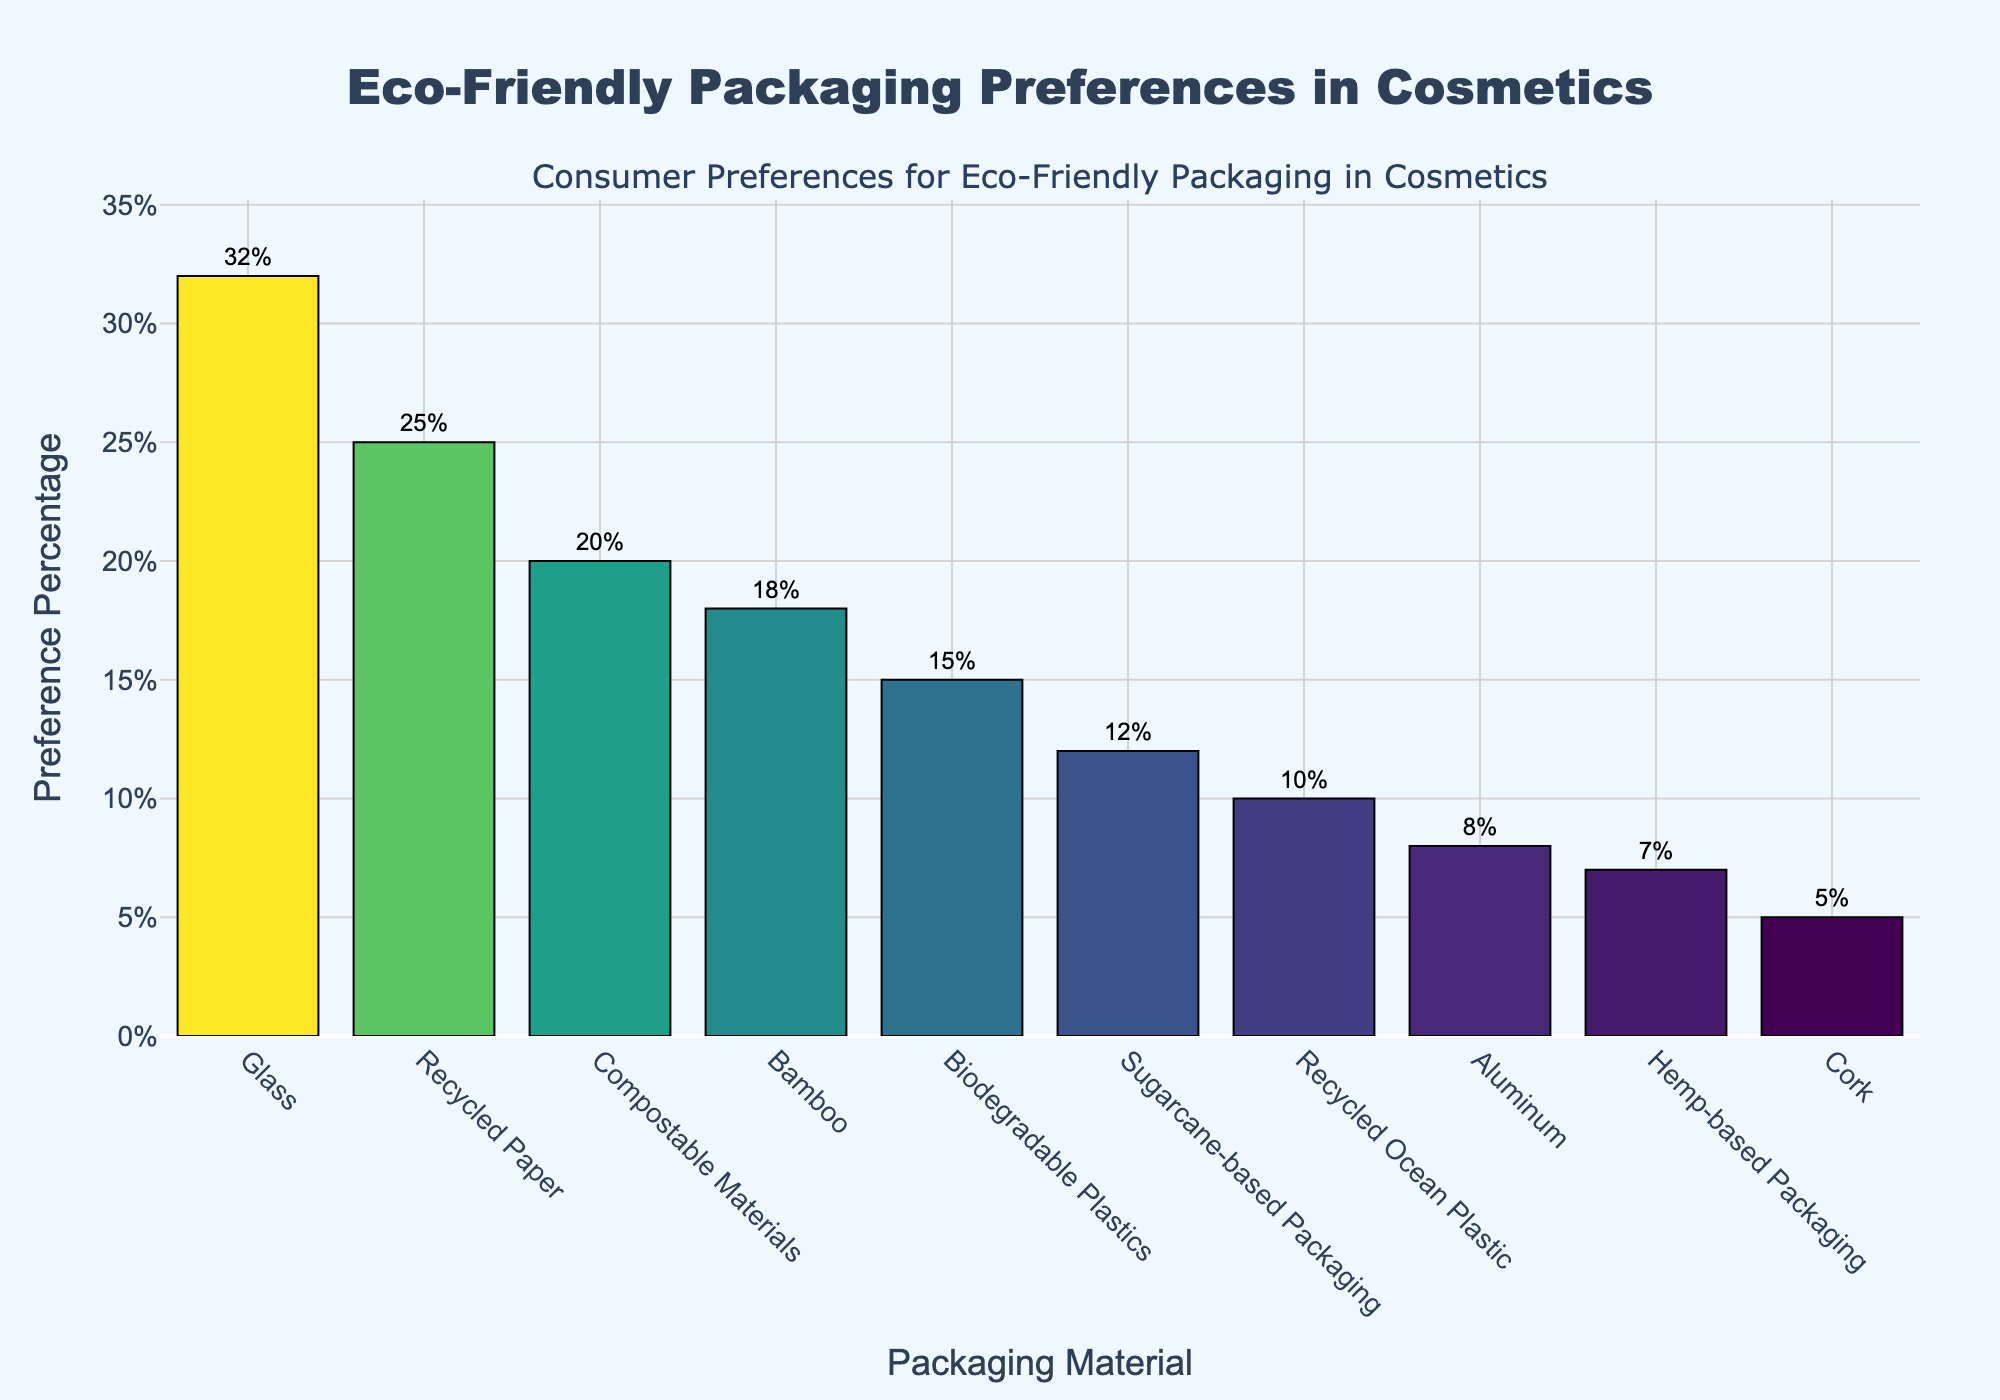Which material is the most preferred for eco-friendly packaging in cosmetics? The figure shows the preference percentages of different materials. By looking at the highest bar, we can see that Glass has the highest preference percentage at 32%.
Answer: Glass Which material is preferred less than Bamboo but more than Aluminum? By examining the heights of the bars, we observe that Recycled Paper (25%) falls between Bamboo (18%) and Aluminum (8%).
Answer: Recycled Paper What is the total preference percentage for the materials with less than 10% preference each? To get the total, we sum the preference percentages of Aluminum (8%), Cork (5%), Hemp-based Packaging (7%), and Recycled Ocean Plastic (10%): 8 + 5 + 7 + 10 = 30%.
Answer: 30% How much more preferred is Glass compared to Biodegradable Plastics? Glass has a preference percentage of 32%, and Biodegradable Plastics have 15%. The difference is 32% - 15% = 17%.
Answer: 17% What is the average preference percentage of Bamboo, Sugarcane-based Packaging, and Hemp-based Packaging? To find the average, sum the preference percentages of Bamboo (18%), Sugarcane-based Packaging (12%), and Hemp-based Packaging (7%), which is 37. Then divide by 3: 37 / 3 ≈ 12.33%.
Answer: 12.33% Which material shown in green has the second-highest preference percentage? By identifying the bars colored as varying shades of green, we see that Recycled Paper (25%) has the second-highest preference after Glass.
Answer: Recycled Paper Which materials combine to make up a quarter (or 25%) of the total preference percentage for all materials shown? First, sum all the preference percentages: 32 + 18 + 25 + 15 + 8 + 12 + 5 + 10 + 20 + 7 = 152%. Then, calculate 25% of 152%: 0.25 * 152 = 38%. Combining Composable Materials (20%) and Biodegradable Plastics (15%) totals 35%. Adding Recycled Ocean Plastic (10%) exceeds 38%, so the best fit is Bamboo (18%) and Recycled Paper (25%) = 25%.
Answer: Bamboo and Recycled Paper 